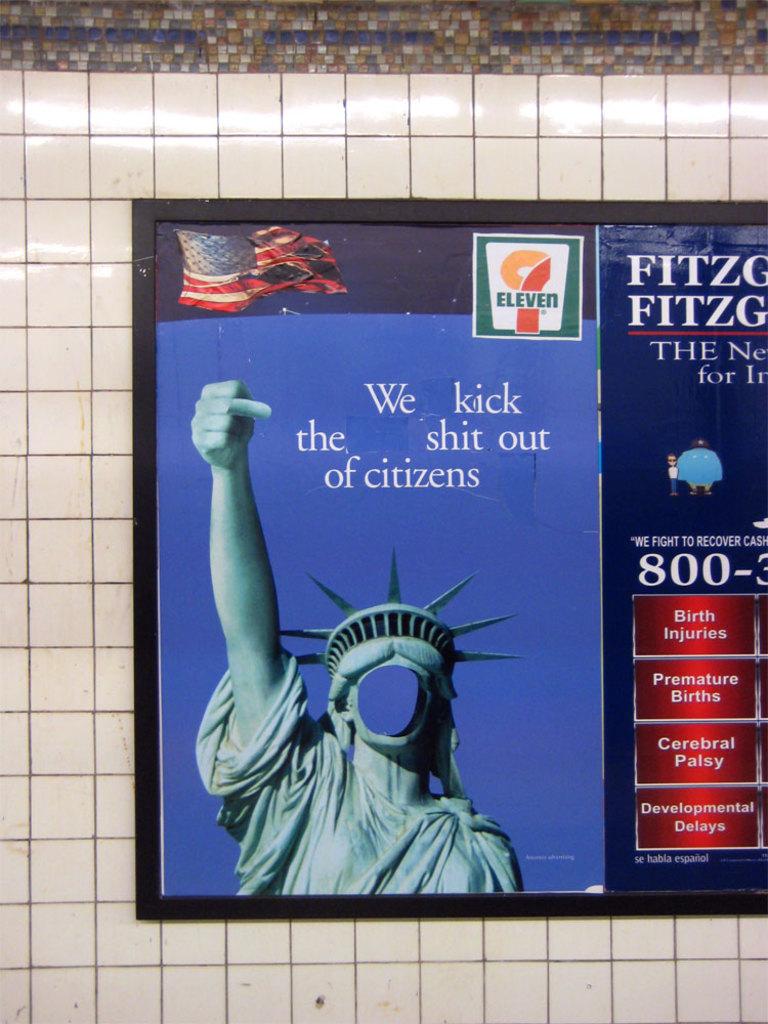Who do they kick?
Provide a succinct answer. Citizens. 